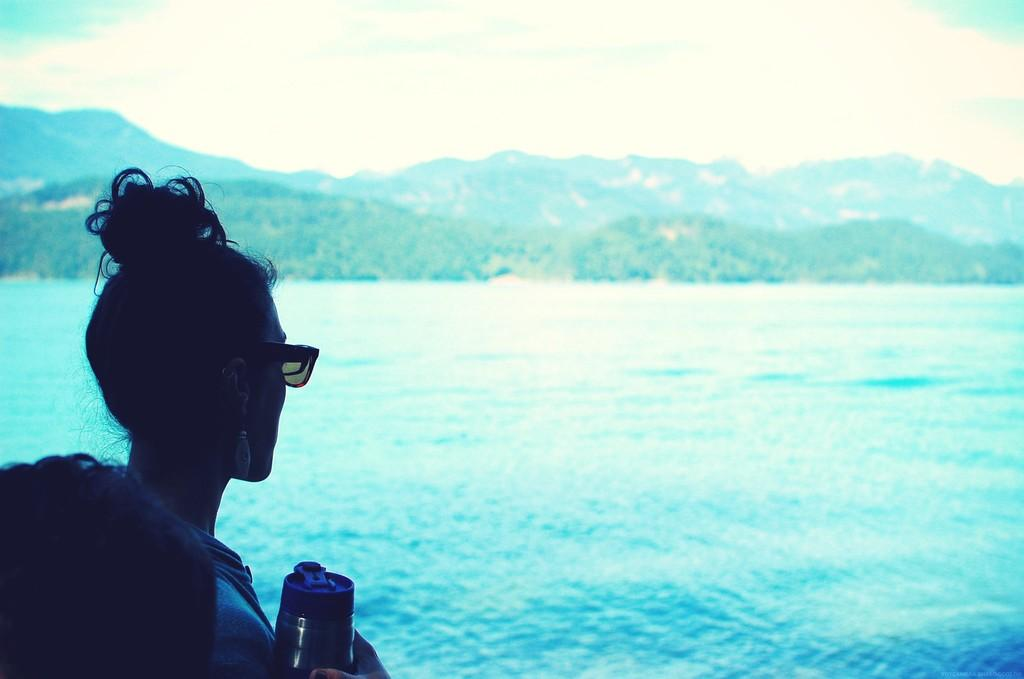What is the person in the image holding? The person is holding a bottle in the image. What type of natural landform can be seen in the image? There is a mountain visible in the image. What type of terrain is visible in the image? There is water and trees visible in the image. What colors are present in the sky in the image? The sky is a combination of white and blue colors in the image. How many passengers are in the car that is driving through the water in the image? There is no car or passengers present in the image; it features a person holding a bottle and a mountain, water, trees, and a sky with white and blue colors. 